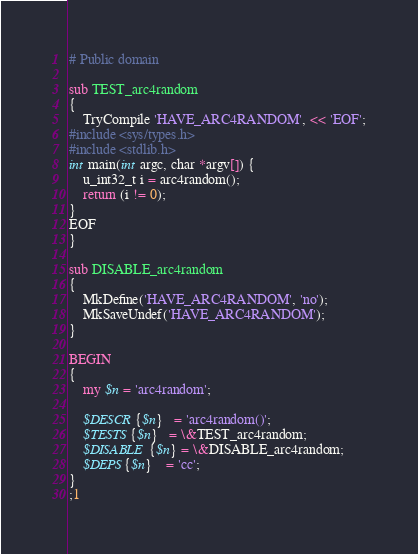Convert code to text. <code><loc_0><loc_0><loc_500><loc_500><_Perl_># Public domain

sub TEST_arc4random
{
	TryCompile 'HAVE_ARC4RANDOM', << 'EOF';
#include <sys/types.h>
#include <stdlib.h>
int main(int argc, char *argv[]) {
	u_int32_t i = arc4random();
	return (i != 0);
}
EOF
}

sub DISABLE_arc4random
{
	MkDefine('HAVE_ARC4RANDOM', 'no');
	MkSaveUndef('HAVE_ARC4RANDOM');
}

BEGIN
{
	my $n = 'arc4random';

	$DESCR{$n}   = 'arc4random()';
	$TESTS{$n}   = \&TEST_arc4random;
	$DISABLE{$n} = \&DISABLE_arc4random;
	$DEPS{$n}    = 'cc';
}
;1
</code> 